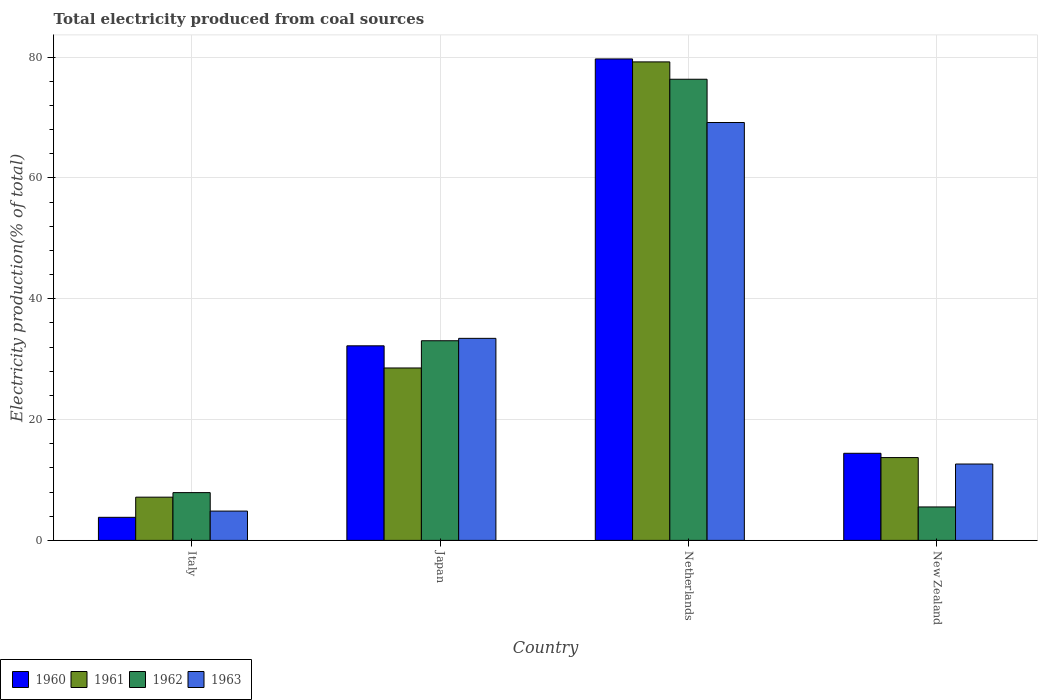How many different coloured bars are there?
Provide a short and direct response. 4. How many groups of bars are there?
Your answer should be very brief. 4. How many bars are there on the 2nd tick from the left?
Provide a succinct answer. 4. In how many cases, is the number of bars for a given country not equal to the number of legend labels?
Your answer should be compact. 0. What is the total electricity produced in 1960 in Japan?
Your answer should be compact. 32.21. Across all countries, what is the maximum total electricity produced in 1963?
Provide a short and direct response. 69.17. Across all countries, what is the minimum total electricity produced in 1960?
Offer a very short reply. 3.82. In which country was the total electricity produced in 1961 maximum?
Keep it short and to the point. Netherlands. What is the total total electricity produced in 1963 in the graph?
Give a very brief answer. 120.11. What is the difference between the total electricity produced in 1961 in Italy and that in Netherlands?
Offer a very short reply. -72.05. What is the difference between the total electricity produced in 1962 in Netherlands and the total electricity produced in 1961 in Italy?
Keep it short and to the point. 69.18. What is the average total electricity produced in 1962 per country?
Give a very brief answer. 30.71. What is the difference between the total electricity produced of/in 1961 and total electricity produced of/in 1962 in Japan?
Offer a very short reply. -4.51. In how many countries, is the total electricity produced in 1962 greater than 4 %?
Your response must be concise. 4. What is the ratio of the total electricity produced in 1963 in Italy to that in Netherlands?
Keep it short and to the point. 0.07. What is the difference between the highest and the second highest total electricity produced in 1963?
Ensure brevity in your answer.  20.8. What is the difference between the highest and the lowest total electricity produced in 1961?
Provide a succinct answer. 72.05. In how many countries, is the total electricity produced in 1960 greater than the average total electricity produced in 1960 taken over all countries?
Offer a terse response. 1. What does the 2nd bar from the left in Italy represents?
Your response must be concise. 1961. What does the 2nd bar from the right in New Zealand represents?
Your answer should be compact. 1962. Is it the case that in every country, the sum of the total electricity produced in 1961 and total electricity produced in 1962 is greater than the total electricity produced in 1963?
Make the answer very short. Yes. How many countries are there in the graph?
Provide a short and direct response. 4. Does the graph contain any zero values?
Make the answer very short. No. Does the graph contain grids?
Give a very brief answer. Yes. What is the title of the graph?
Keep it short and to the point. Total electricity produced from coal sources. Does "2015" appear as one of the legend labels in the graph?
Offer a very short reply. No. What is the Electricity production(% of total) in 1960 in Italy?
Keep it short and to the point. 3.82. What is the Electricity production(% of total) in 1961 in Italy?
Your answer should be compact. 7.15. What is the Electricity production(% of total) of 1962 in Italy?
Your response must be concise. 7.91. What is the Electricity production(% of total) of 1963 in Italy?
Offer a terse response. 4.85. What is the Electricity production(% of total) of 1960 in Japan?
Keep it short and to the point. 32.21. What is the Electricity production(% of total) of 1961 in Japan?
Keep it short and to the point. 28.54. What is the Electricity production(% of total) in 1962 in Japan?
Offer a terse response. 33.05. What is the Electricity production(% of total) in 1963 in Japan?
Make the answer very short. 33.44. What is the Electricity production(% of total) of 1960 in Netherlands?
Ensure brevity in your answer.  79.69. What is the Electricity production(% of total) in 1961 in Netherlands?
Provide a short and direct response. 79.2. What is the Electricity production(% of total) in 1962 in Netherlands?
Your response must be concise. 76.33. What is the Electricity production(% of total) of 1963 in Netherlands?
Make the answer very short. 69.17. What is the Electricity production(% of total) in 1960 in New Zealand?
Your response must be concise. 14.42. What is the Electricity production(% of total) of 1961 in New Zealand?
Make the answer very short. 13.71. What is the Electricity production(% of total) of 1962 in New Zealand?
Your response must be concise. 5.54. What is the Electricity production(% of total) in 1963 in New Zealand?
Offer a very short reply. 12.64. Across all countries, what is the maximum Electricity production(% of total) in 1960?
Offer a very short reply. 79.69. Across all countries, what is the maximum Electricity production(% of total) of 1961?
Your response must be concise. 79.2. Across all countries, what is the maximum Electricity production(% of total) of 1962?
Offer a very short reply. 76.33. Across all countries, what is the maximum Electricity production(% of total) in 1963?
Your answer should be very brief. 69.17. Across all countries, what is the minimum Electricity production(% of total) in 1960?
Provide a short and direct response. 3.82. Across all countries, what is the minimum Electricity production(% of total) in 1961?
Provide a short and direct response. 7.15. Across all countries, what is the minimum Electricity production(% of total) in 1962?
Make the answer very short. 5.54. Across all countries, what is the minimum Electricity production(% of total) of 1963?
Your answer should be compact. 4.85. What is the total Electricity production(% of total) of 1960 in the graph?
Your answer should be very brief. 130.14. What is the total Electricity production(% of total) in 1961 in the graph?
Provide a succinct answer. 128.61. What is the total Electricity production(% of total) of 1962 in the graph?
Your answer should be compact. 122.83. What is the total Electricity production(% of total) of 1963 in the graph?
Ensure brevity in your answer.  120.11. What is the difference between the Electricity production(% of total) in 1960 in Italy and that in Japan?
Your response must be concise. -28.39. What is the difference between the Electricity production(% of total) of 1961 in Italy and that in Japan?
Your answer should be very brief. -21.38. What is the difference between the Electricity production(% of total) in 1962 in Italy and that in Japan?
Keep it short and to the point. -25.14. What is the difference between the Electricity production(% of total) of 1963 in Italy and that in Japan?
Your response must be concise. -28.59. What is the difference between the Electricity production(% of total) in 1960 in Italy and that in Netherlands?
Offer a terse response. -75.87. What is the difference between the Electricity production(% of total) of 1961 in Italy and that in Netherlands?
Offer a very short reply. -72.05. What is the difference between the Electricity production(% of total) of 1962 in Italy and that in Netherlands?
Provide a short and direct response. -68.42. What is the difference between the Electricity production(% of total) in 1963 in Italy and that in Netherlands?
Your response must be concise. -64.32. What is the difference between the Electricity production(% of total) of 1960 in Italy and that in New Zealand?
Offer a terse response. -10.6. What is the difference between the Electricity production(% of total) in 1961 in Italy and that in New Zealand?
Your answer should be very brief. -6.55. What is the difference between the Electricity production(% of total) in 1962 in Italy and that in New Zealand?
Your response must be concise. 2.37. What is the difference between the Electricity production(% of total) in 1963 in Italy and that in New Zealand?
Your response must be concise. -7.79. What is the difference between the Electricity production(% of total) of 1960 in Japan and that in Netherlands?
Your answer should be very brief. -47.48. What is the difference between the Electricity production(% of total) in 1961 in Japan and that in Netherlands?
Keep it short and to the point. -50.67. What is the difference between the Electricity production(% of total) of 1962 in Japan and that in Netherlands?
Keep it short and to the point. -43.28. What is the difference between the Electricity production(% of total) of 1963 in Japan and that in Netherlands?
Your answer should be compact. -35.73. What is the difference between the Electricity production(% of total) in 1960 in Japan and that in New Zealand?
Make the answer very short. 17.79. What is the difference between the Electricity production(% of total) in 1961 in Japan and that in New Zealand?
Offer a very short reply. 14.83. What is the difference between the Electricity production(% of total) in 1962 in Japan and that in New Zealand?
Your answer should be very brief. 27.51. What is the difference between the Electricity production(% of total) of 1963 in Japan and that in New Zealand?
Provide a short and direct response. 20.8. What is the difference between the Electricity production(% of total) in 1960 in Netherlands and that in New Zealand?
Your answer should be very brief. 65.28. What is the difference between the Electricity production(% of total) in 1961 in Netherlands and that in New Zealand?
Your answer should be very brief. 65.5. What is the difference between the Electricity production(% of total) in 1962 in Netherlands and that in New Zealand?
Keep it short and to the point. 70.8. What is the difference between the Electricity production(% of total) of 1963 in Netherlands and that in New Zealand?
Keep it short and to the point. 56.53. What is the difference between the Electricity production(% of total) of 1960 in Italy and the Electricity production(% of total) of 1961 in Japan?
Provide a short and direct response. -24.72. What is the difference between the Electricity production(% of total) of 1960 in Italy and the Electricity production(% of total) of 1962 in Japan?
Keep it short and to the point. -29.23. What is the difference between the Electricity production(% of total) of 1960 in Italy and the Electricity production(% of total) of 1963 in Japan?
Offer a terse response. -29.63. What is the difference between the Electricity production(% of total) in 1961 in Italy and the Electricity production(% of total) in 1962 in Japan?
Make the answer very short. -25.89. What is the difference between the Electricity production(% of total) of 1961 in Italy and the Electricity production(% of total) of 1963 in Japan?
Make the answer very short. -26.29. What is the difference between the Electricity production(% of total) of 1962 in Italy and the Electricity production(% of total) of 1963 in Japan?
Your answer should be very brief. -25.53. What is the difference between the Electricity production(% of total) in 1960 in Italy and the Electricity production(% of total) in 1961 in Netherlands?
Ensure brevity in your answer.  -75.39. What is the difference between the Electricity production(% of total) in 1960 in Italy and the Electricity production(% of total) in 1962 in Netherlands?
Give a very brief answer. -72.51. What is the difference between the Electricity production(% of total) of 1960 in Italy and the Electricity production(% of total) of 1963 in Netherlands?
Your answer should be very brief. -65.35. What is the difference between the Electricity production(% of total) of 1961 in Italy and the Electricity production(% of total) of 1962 in Netherlands?
Offer a very short reply. -69.18. What is the difference between the Electricity production(% of total) of 1961 in Italy and the Electricity production(% of total) of 1963 in Netherlands?
Provide a short and direct response. -62.02. What is the difference between the Electricity production(% of total) in 1962 in Italy and the Electricity production(% of total) in 1963 in Netherlands?
Your answer should be compact. -61.26. What is the difference between the Electricity production(% of total) in 1960 in Italy and the Electricity production(% of total) in 1961 in New Zealand?
Your answer should be very brief. -9.89. What is the difference between the Electricity production(% of total) in 1960 in Italy and the Electricity production(% of total) in 1962 in New Zealand?
Offer a very short reply. -1.72. What is the difference between the Electricity production(% of total) in 1960 in Italy and the Electricity production(% of total) in 1963 in New Zealand?
Make the answer very short. -8.82. What is the difference between the Electricity production(% of total) of 1961 in Italy and the Electricity production(% of total) of 1962 in New Zealand?
Offer a very short reply. 1.62. What is the difference between the Electricity production(% of total) in 1961 in Italy and the Electricity production(% of total) in 1963 in New Zealand?
Ensure brevity in your answer.  -5.49. What is the difference between the Electricity production(% of total) in 1962 in Italy and the Electricity production(% of total) in 1963 in New Zealand?
Make the answer very short. -4.73. What is the difference between the Electricity production(% of total) of 1960 in Japan and the Electricity production(% of total) of 1961 in Netherlands?
Provide a succinct answer. -47. What is the difference between the Electricity production(% of total) in 1960 in Japan and the Electricity production(% of total) in 1962 in Netherlands?
Make the answer very short. -44.13. What is the difference between the Electricity production(% of total) of 1960 in Japan and the Electricity production(% of total) of 1963 in Netherlands?
Your answer should be compact. -36.96. What is the difference between the Electricity production(% of total) in 1961 in Japan and the Electricity production(% of total) in 1962 in Netherlands?
Your answer should be very brief. -47.79. What is the difference between the Electricity production(% of total) in 1961 in Japan and the Electricity production(% of total) in 1963 in Netherlands?
Keep it short and to the point. -40.63. What is the difference between the Electricity production(% of total) of 1962 in Japan and the Electricity production(% of total) of 1963 in Netherlands?
Your answer should be very brief. -36.12. What is the difference between the Electricity production(% of total) of 1960 in Japan and the Electricity production(% of total) of 1961 in New Zealand?
Your answer should be compact. 18.5. What is the difference between the Electricity production(% of total) in 1960 in Japan and the Electricity production(% of total) in 1962 in New Zealand?
Your response must be concise. 26.67. What is the difference between the Electricity production(% of total) of 1960 in Japan and the Electricity production(% of total) of 1963 in New Zealand?
Your answer should be very brief. 19.57. What is the difference between the Electricity production(% of total) in 1961 in Japan and the Electricity production(% of total) in 1962 in New Zealand?
Offer a very short reply. 23. What is the difference between the Electricity production(% of total) in 1961 in Japan and the Electricity production(% of total) in 1963 in New Zealand?
Give a very brief answer. 15.9. What is the difference between the Electricity production(% of total) of 1962 in Japan and the Electricity production(% of total) of 1963 in New Zealand?
Offer a terse response. 20.41. What is the difference between the Electricity production(% of total) of 1960 in Netherlands and the Electricity production(% of total) of 1961 in New Zealand?
Keep it short and to the point. 65.98. What is the difference between the Electricity production(% of total) in 1960 in Netherlands and the Electricity production(% of total) in 1962 in New Zealand?
Ensure brevity in your answer.  74.16. What is the difference between the Electricity production(% of total) of 1960 in Netherlands and the Electricity production(% of total) of 1963 in New Zealand?
Your answer should be very brief. 67.05. What is the difference between the Electricity production(% of total) of 1961 in Netherlands and the Electricity production(% of total) of 1962 in New Zealand?
Make the answer very short. 73.67. What is the difference between the Electricity production(% of total) in 1961 in Netherlands and the Electricity production(% of total) in 1963 in New Zealand?
Make the answer very short. 66.56. What is the difference between the Electricity production(% of total) of 1962 in Netherlands and the Electricity production(% of total) of 1963 in New Zealand?
Your response must be concise. 63.69. What is the average Electricity production(% of total) of 1960 per country?
Provide a short and direct response. 32.53. What is the average Electricity production(% of total) in 1961 per country?
Make the answer very short. 32.15. What is the average Electricity production(% of total) of 1962 per country?
Offer a terse response. 30.71. What is the average Electricity production(% of total) of 1963 per country?
Your answer should be very brief. 30.03. What is the difference between the Electricity production(% of total) in 1960 and Electricity production(% of total) in 1961 in Italy?
Ensure brevity in your answer.  -3.34. What is the difference between the Electricity production(% of total) of 1960 and Electricity production(% of total) of 1962 in Italy?
Make the answer very short. -4.09. What is the difference between the Electricity production(% of total) of 1960 and Electricity production(% of total) of 1963 in Italy?
Make the answer very short. -1.03. What is the difference between the Electricity production(% of total) in 1961 and Electricity production(% of total) in 1962 in Italy?
Offer a terse response. -0.75. What is the difference between the Electricity production(% of total) in 1961 and Electricity production(% of total) in 1963 in Italy?
Offer a terse response. 2.3. What is the difference between the Electricity production(% of total) in 1962 and Electricity production(% of total) in 1963 in Italy?
Offer a terse response. 3.06. What is the difference between the Electricity production(% of total) in 1960 and Electricity production(% of total) in 1961 in Japan?
Your response must be concise. 3.67. What is the difference between the Electricity production(% of total) of 1960 and Electricity production(% of total) of 1962 in Japan?
Offer a terse response. -0.84. What is the difference between the Electricity production(% of total) of 1960 and Electricity production(% of total) of 1963 in Japan?
Give a very brief answer. -1.24. What is the difference between the Electricity production(% of total) in 1961 and Electricity production(% of total) in 1962 in Japan?
Provide a succinct answer. -4.51. What is the difference between the Electricity production(% of total) in 1961 and Electricity production(% of total) in 1963 in Japan?
Provide a succinct answer. -4.9. What is the difference between the Electricity production(% of total) in 1962 and Electricity production(% of total) in 1963 in Japan?
Provide a succinct answer. -0.4. What is the difference between the Electricity production(% of total) in 1960 and Electricity production(% of total) in 1961 in Netherlands?
Keep it short and to the point. 0.49. What is the difference between the Electricity production(% of total) of 1960 and Electricity production(% of total) of 1962 in Netherlands?
Your response must be concise. 3.36. What is the difference between the Electricity production(% of total) of 1960 and Electricity production(% of total) of 1963 in Netherlands?
Your answer should be very brief. 10.52. What is the difference between the Electricity production(% of total) of 1961 and Electricity production(% of total) of 1962 in Netherlands?
Ensure brevity in your answer.  2.87. What is the difference between the Electricity production(% of total) of 1961 and Electricity production(% of total) of 1963 in Netherlands?
Your answer should be very brief. 10.03. What is the difference between the Electricity production(% of total) of 1962 and Electricity production(% of total) of 1963 in Netherlands?
Give a very brief answer. 7.16. What is the difference between the Electricity production(% of total) in 1960 and Electricity production(% of total) in 1961 in New Zealand?
Give a very brief answer. 0.71. What is the difference between the Electricity production(% of total) in 1960 and Electricity production(% of total) in 1962 in New Zealand?
Keep it short and to the point. 8.88. What is the difference between the Electricity production(% of total) of 1960 and Electricity production(% of total) of 1963 in New Zealand?
Offer a terse response. 1.78. What is the difference between the Electricity production(% of total) of 1961 and Electricity production(% of total) of 1962 in New Zealand?
Offer a very short reply. 8.17. What is the difference between the Electricity production(% of total) of 1961 and Electricity production(% of total) of 1963 in New Zealand?
Your answer should be compact. 1.07. What is the difference between the Electricity production(% of total) in 1962 and Electricity production(% of total) in 1963 in New Zealand?
Your response must be concise. -7.1. What is the ratio of the Electricity production(% of total) of 1960 in Italy to that in Japan?
Keep it short and to the point. 0.12. What is the ratio of the Electricity production(% of total) in 1961 in Italy to that in Japan?
Your answer should be very brief. 0.25. What is the ratio of the Electricity production(% of total) in 1962 in Italy to that in Japan?
Offer a terse response. 0.24. What is the ratio of the Electricity production(% of total) of 1963 in Italy to that in Japan?
Offer a very short reply. 0.15. What is the ratio of the Electricity production(% of total) in 1960 in Italy to that in Netherlands?
Your response must be concise. 0.05. What is the ratio of the Electricity production(% of total) in 1961 in Italy to that in Netherlands?
Give a very brief answer. 0.09. What is the ratio of the Electricity production(% of total) in 1962 in Italy to that in Netherlands?
Offer a terse response. 0.1. What is the ratio of the Electricity production(% of total) in 1963 in Italy to that in Netherlands?
Offer a very short reply. 0.07. What is the ratio of the Electricity production(% of total) in 1960 in Italy to that in New Zealand?
Your answer should be very brief. 0.26. What is the ratio of the Electricity production(% of total) of 1961 in Italy to that in New Zealand?
Your response must be concise. 0.52. What is the ratio of the Electricity production(% of total) of 1962 in Italy to that in New Zealand?
Provide a succinct answer. 1.43. What is the ratio of the Electricity production(% of total) in 1963 in Italy to that in New Zealand?
Offer a terse response. 0.38. What is the ratio of the Electricity production(% of total) in 1960 in Japan to that in Netherlands?
Keep it short and to the point. 0.4. What is the ratio of the Electricity production(% of total) of 1961 in Japan to that in Netherlands?
Provide a short and direct response. 0.36. What is the ratio of the Electricity production(% of total) of 1962 in Japan to that in Netherlands?
Give a very brief answer. 0.43. What is the ratio of the Electricity production(% of total) in 1963 in Japan to that in Netherlands?
Your answer should be very brief. 0.48. What is the ratio of the Electricity production(% of total) of 1960 in Japan to that in New Zealand?
Give a very brief answer. 2.23. What is the ratio of the Electricity production(% of total) of 1961 in Japan to that in New Zealand?
Keep it short and to the point. 2.08. What is the ratio of the Electricity production(% of total) in 1962 in Japan to that in New Zealand?
Offer a terse response. 5.97. What is the ratio of the Electricity production(% of total) in 1963 in Japan to that in New Zealand?
Keep it short and to the point. 2.65. What is the ratio of the Electricity production(% of total) of 1960 in Netherlands to that in New Zealand?
Make the answer very short. 5.53. What is the ratio of the Electricity production(% of total) of 1961 in Netherlands to that in New Zealand?
Provide a short and direct response. 5.78. What is the ratio of the Electricity production(% of total) of 1962 in Netherlands to that in New Zealand?
Provide a short and direct response. 13.79. What is the ratio of the Electricity production(% of total) in 1963 in Netherlands to that in New Zealand?
Ensure brevity in your answer.  5.47. What is the difference between the highest and the second highest Electricity production(% of total) in 1960?
Make the answer very short. 47.48. What is the difference between the highest and the second highest Electricity production(% of total) of 1961?
Provide a short and direct response. 50.67. What is the difference between the highest and the second highest Electricity production(% of total) of 1962?
Offer a terse response. 43.28. What is the difference between the highest and the second highest Electricity production(% of total) of 1963?
Offer a very short reply. 35.73. What is the difference between the highest and the lowest Electricity production(% of total) of 1960?
Keep it short and to the point. 75.87. What is the difference between the highest and the lowest Electricity production(% of total) of 1961?
Your response must be concise. 72.05. What is the difference between the highest and the lowest Electricity production(% of total) in 1962?
Your response must be concise. 70.8. What is the difference between the highest and the lowest Electricity production(% of total) of 1963?
Make the answer very short. 64.32. 